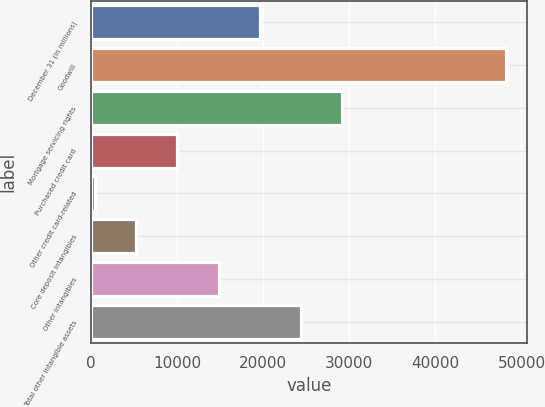Convert chart to OTSL. <chart><loc_0><loc_0><loc_500><loc_500><bar_chart><fcel>December 31 (in millions)<fcel>Goodwill<fcel>Mortgage servicing rights<fcel>Purchased credit card<fcel>Other credit card-related<fcel>Core deposit intangibles<fcel>Other intangibles<fcel>Total other intangible assets<nl><fcel>19568<fcel>48188<fcel>29108<fcel>10028<fcel>488<fcel>5258<fcel>14798<fcel>24338<nl></chart> 